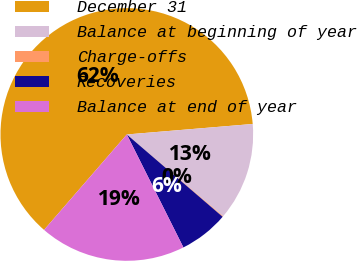Convert chart. <chart><loc_0><loc_0><loc_500><loc_500><pie_chart><fcel>December 31<fcel>Balance at beginning of year<fcel>Charge-offs<fcel>Recoveries<fcel>Balance at end of year<nl><fcel>62.3%<fcel>12.53%<fcel>0.09%<fcel>6.31%<fcel>18.76%<nl></chart> 